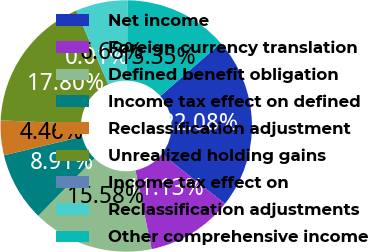<chart> <loc_0><loc_0><loc_500><loc_500><pie_chart><fcel>Net income<fcel>Foreign currency translation<fcel>Defined benefit obligation<fcel>Income tax effect on defined<fcel>Reclassification adjustment<fcel>Unrealized holding gains<fcel>Income tax effect on<fcel>Reclassification adjustments<fcel>Other comprehensive income<nl><fcel>22.08%<fcel>11.13%<fcel>15.58%<fcel>8.91%<fcel>4.46%<fcel>17.8%<fcel>0.01%<fcel>6.68%<fcel>13.35%<nl></chart> 